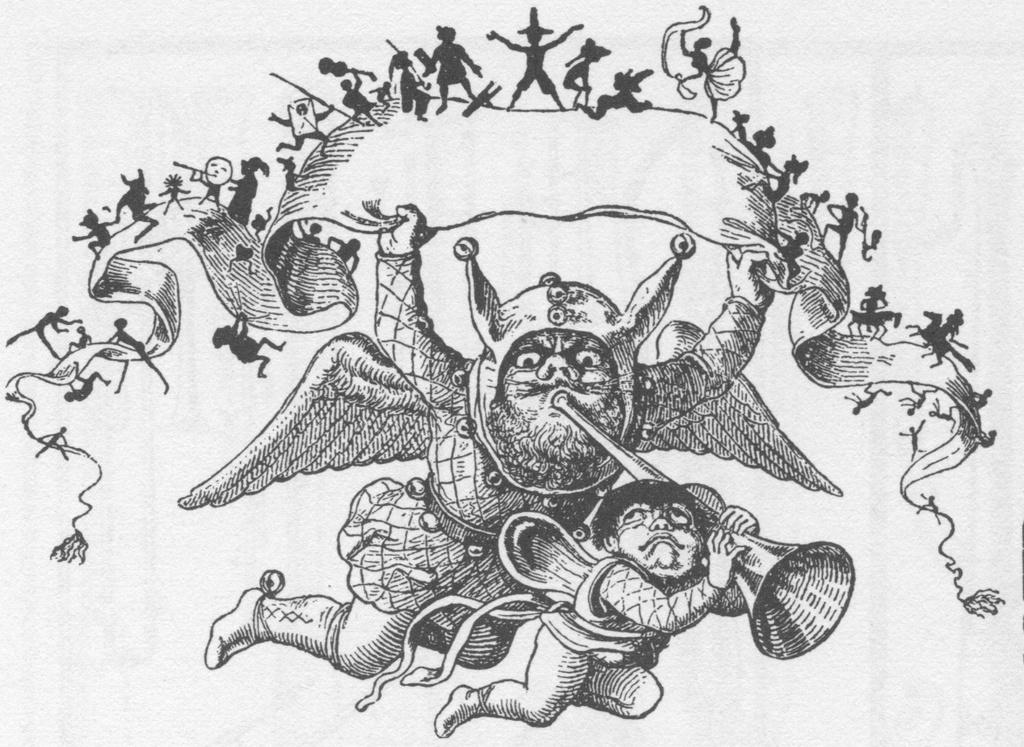What is present on the paper in the image? The paper contains a picture. What does the picture depict? The picture depicts two persons. How is the picture on the paper created? The picture appears to be a drawing. What type of memory is stored in the paper? The paper does not store memory; it contains a picture of two persons. 